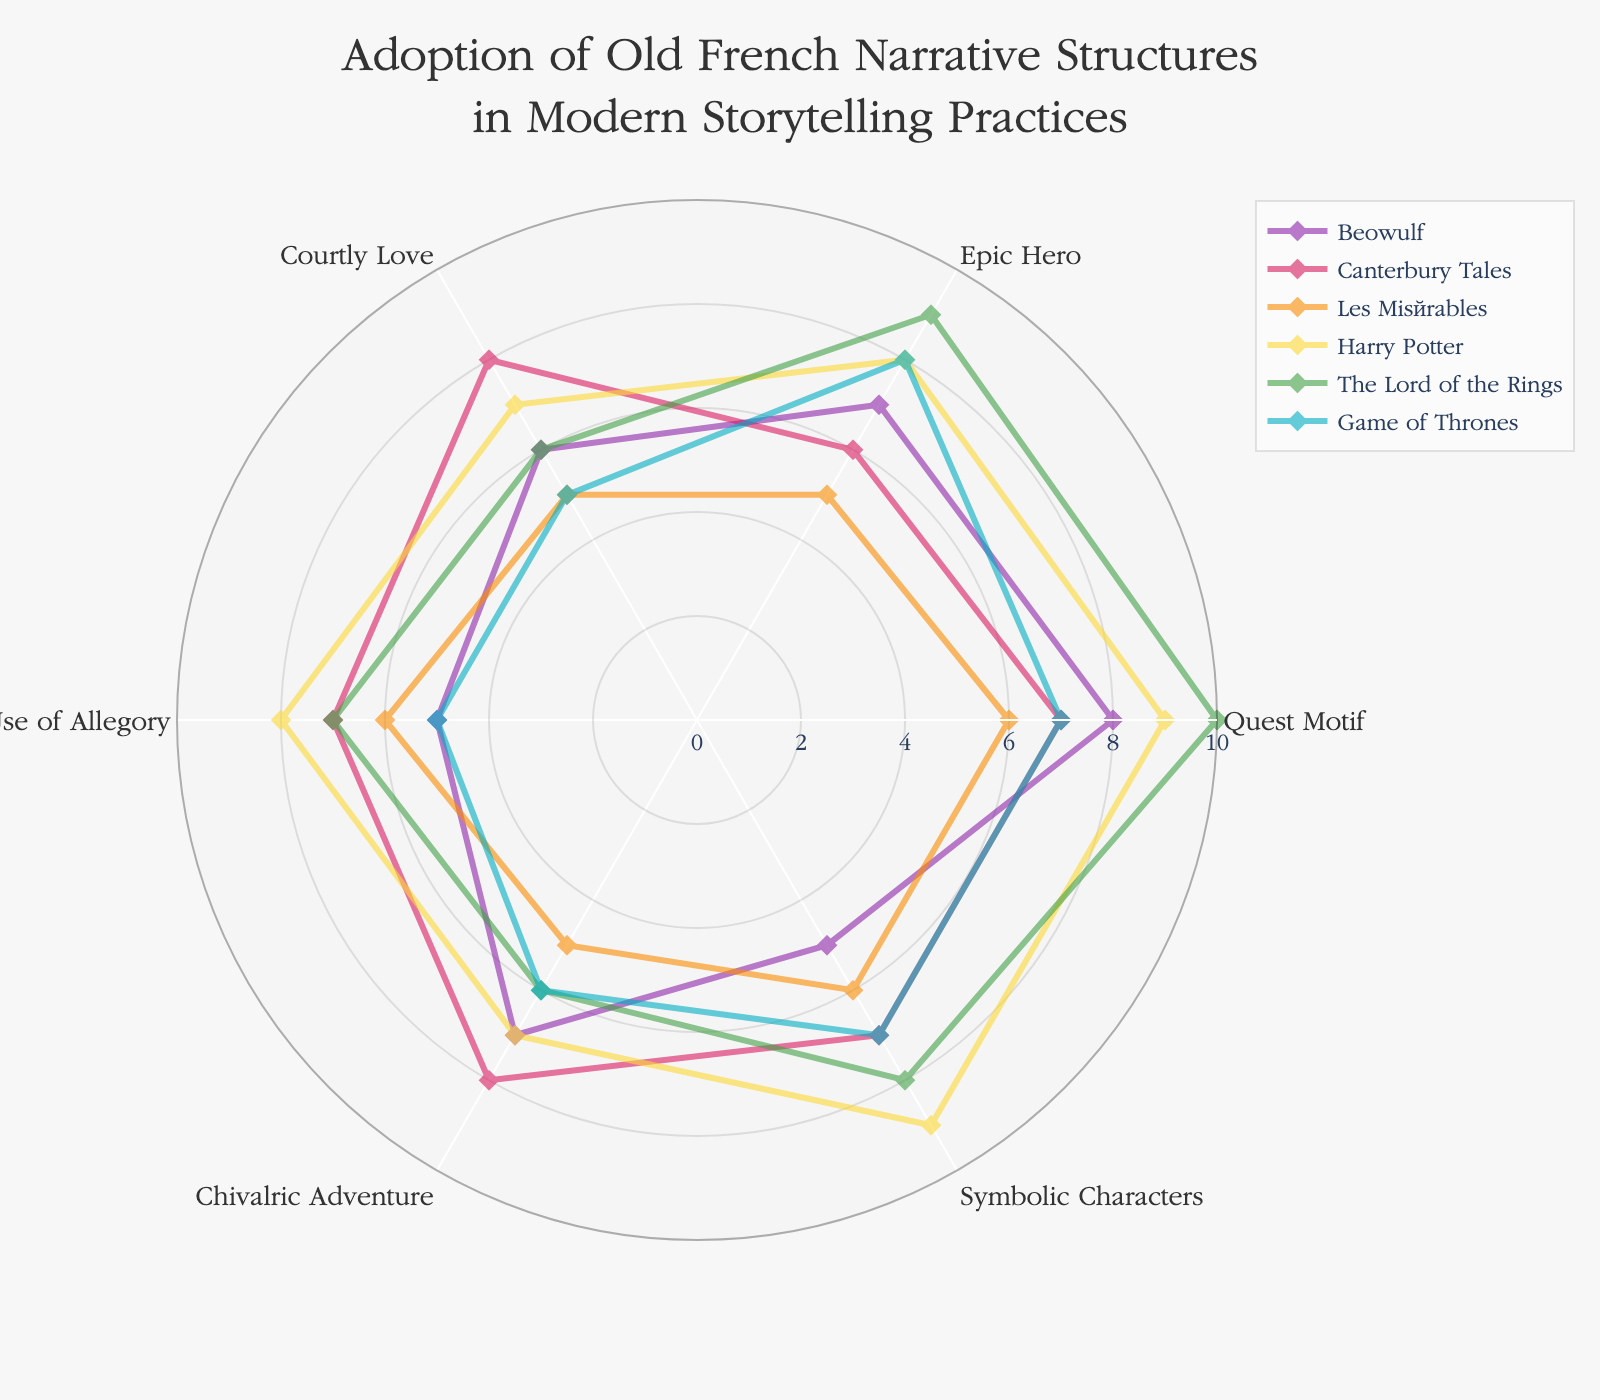Which narrative structure is the most prominent in 'The Lord of the Rings'? By looking at the spoken chart, 'The Quest Motif' has the highest value for 'The Lord of the Rings' compared to other narrative structures.
Answer: Quest Motif What's the average value of 'Epic Hero' across all works? Values for 'Epic Hero' are (7, 6, 5, 8, 9, 8). Sum these values: 43. The number of works is 6. So, 43 ÷ 6 ≈ 7.17.
Answer: 7.17 Which work has the highest incidence of 'Courtly Love'? From the chart, the work with the highest point on the 'Courtly Love' axis is 'Canterbury Tales' with a value of 8.
Answer: Canterbury Tales Which narrative structure has the same adoption level in both 'Canterbury Tales' and 'Harry Potter'? Referring to the chart, both 'Canterbury Tales' and 'Harry Potter' have a value of 7 for 'Chivalric Adventure'.
Answer: Chivalric Adventure Which work has the greatest variation in narrative structures? By comparing the marks' spread on the chart for different works, 'Les Misérables' shows the greatest variation, ranging from 5 (for several structures) to 6.
Answer: Les Misérables What is the difference in the adoption level of 'Use of Allegory' between 'Beowulf' and 'The Lord of the Rings'? 'Use of Allegory' is 5 in 'Beowulf' and 7 in 'The Lord of the Rings'. The difference is 7 - 5 = 2.
Answer: 2 Which work incorporates 'Symbolic Characters' the most? By observing the data, 'Harry Potter' has the highest value for 'Symbolic Characters' at 9.
Answer: Harry Potter What is the least adopted narrative structure in 'Game of Thrones'? According to the chart, 'Courtly Love' and 'Use of Allegory' both share the lowest value of 5 for 'Game of Thrones'.
Answer: Courtly Love and Use of Allegory How many values in 'The Lord of the Rings' are above 7? Reviewing the values for 'The Lord of the Rings', there are 3 values above 7: Quest Motif (10), Epic Hero (9), and Symbolic Characters (8).
Answer: 3 What is the combined total value for 'Courtly Love' across all works? Values for 'Courtly Love' are (6, 8, 5, 7, 6, 5). Sum these values: 6 + 8 + 5 + 7 + 6 + 5 = 37.
Answer: 37 